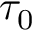Convert formula to latex. <formula><loc_0><loc_0><loc_500><loc_500>\tau _ { 0 }</formula> 